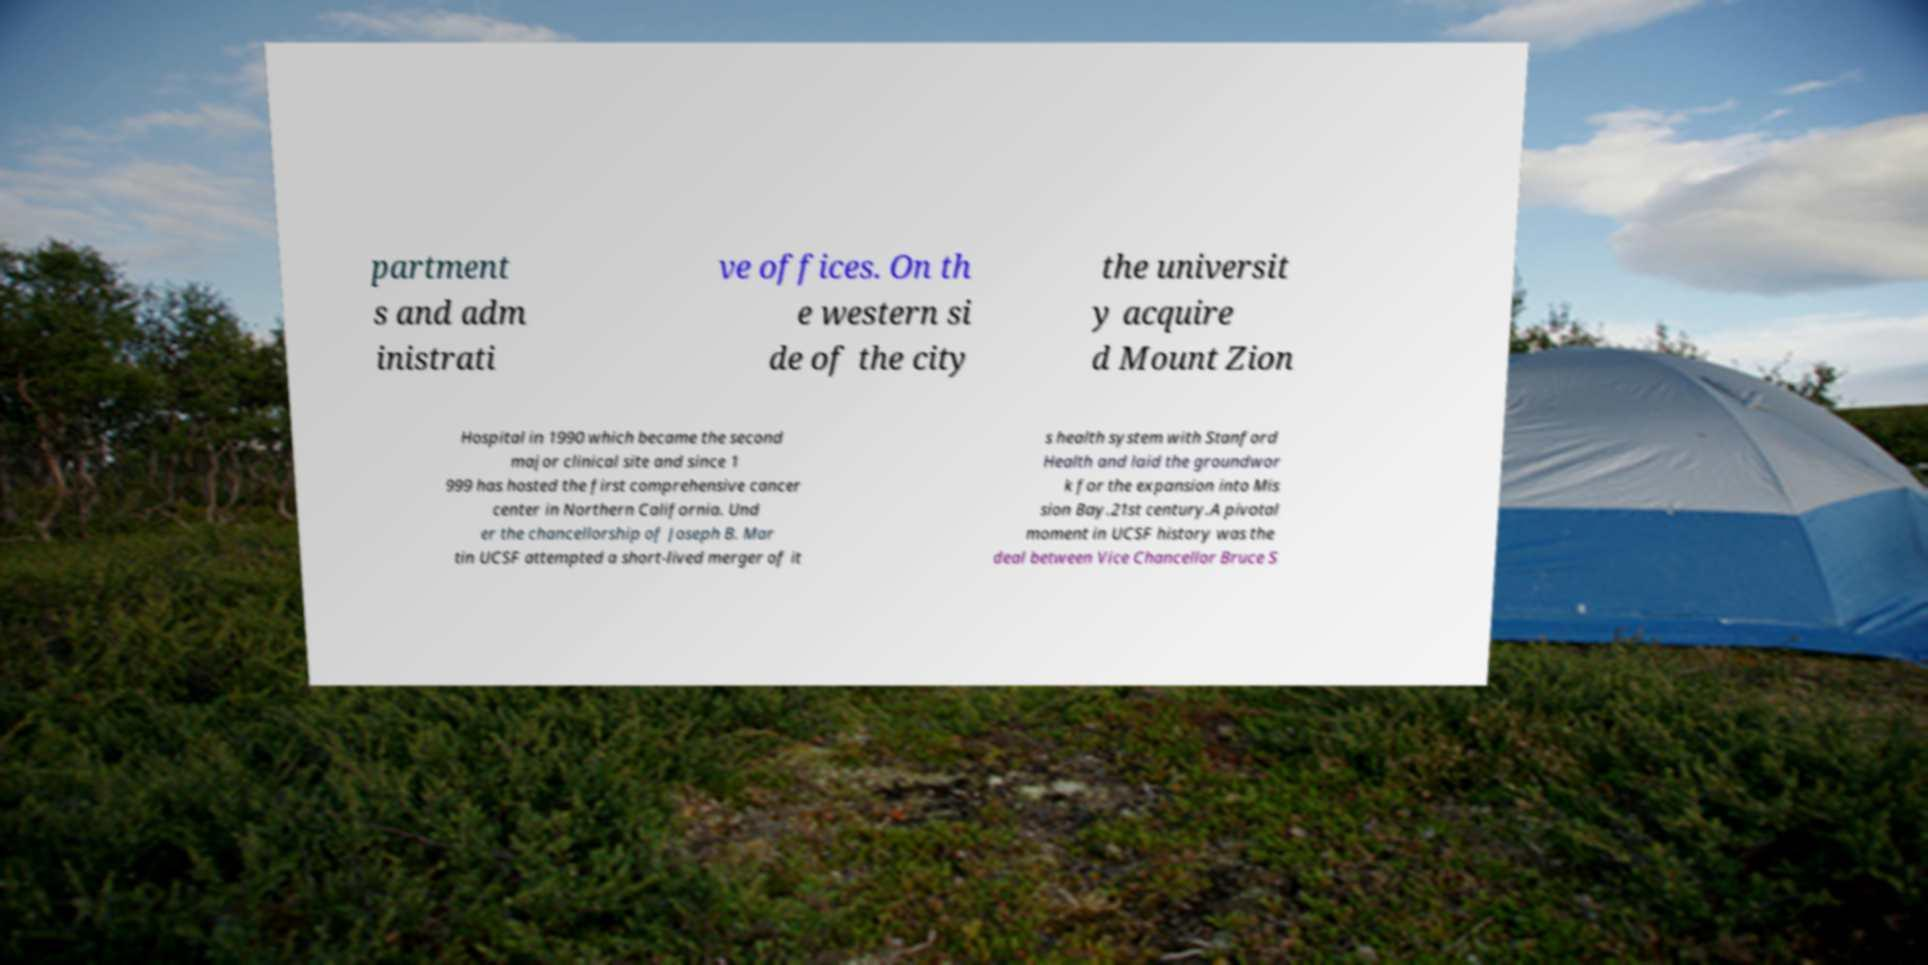What messages or text are displayed in this image? I need them in a readable, typed format. partment s and adm inistrati ve offices. On th e western si de of the city the universit y acquire d Mount Zion Hospital in 1990 which became the second major clinical site and since 1 999 has hosted the first comprehensive cancer center in Northern California. Und er the chancellorship of Joseph B. Mar tin UCSF attempted a short-lived merger of it s health system with Stanford Health and laid the groundwor k for the expansion into Mis sion Bay.21st century.A pivotal moment in UCSF history was the deal between Vice Chancellor Bruce S 